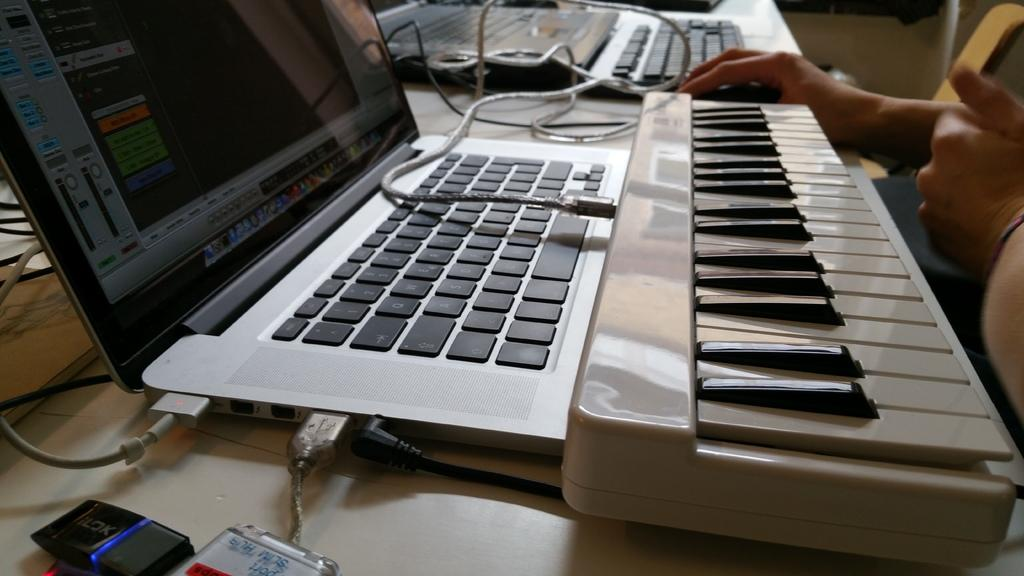What electronic device is located in the middle of the image? There is a laptop in the middle of the image. What other musical instrument can be seen in the image besides the laptop? There is a piano in the image. What is the color of the piano? The piano is white in color. On which side of the image is the piano located? The piano is on the right side of the image. What type of lumber is being traded in the image? There is no reference to lumber or trade in the image; it features a laptop and a piano. How many dolls are sitting on the piano in the image? There are no dolls present in the image. 